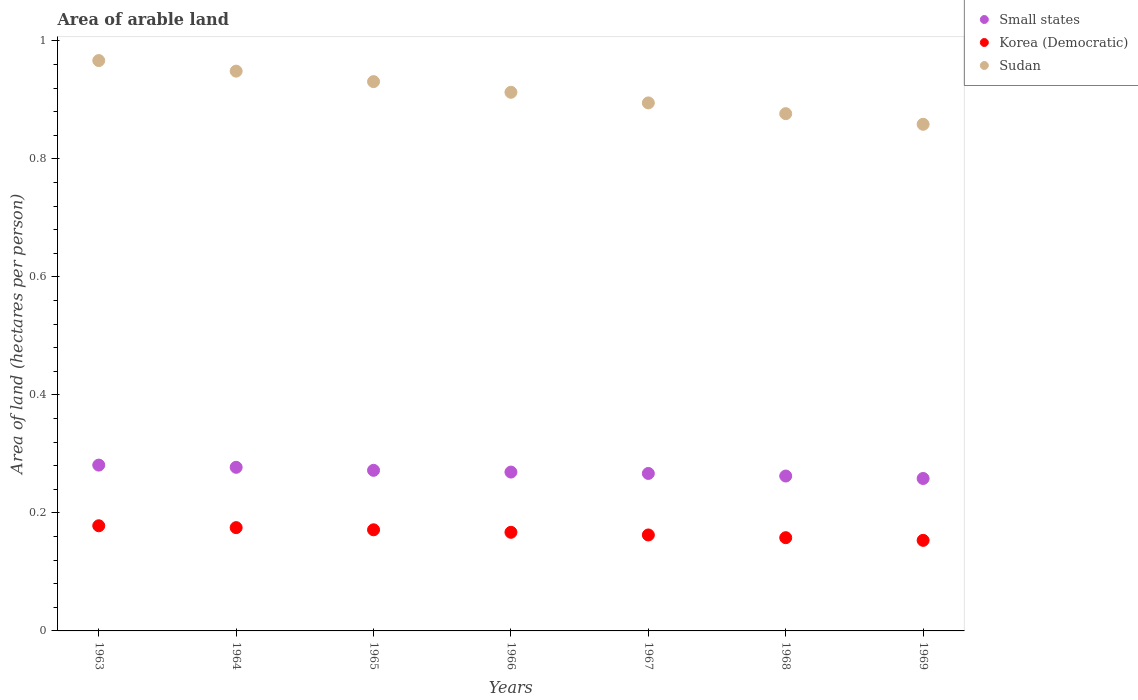How many different coloured dotlines are there?
Provide a short and direct response. 3. Is the number of dotlines equal to the number of legend labels?
Your answer should be compact. Yes. What is the total arable land in Sudan in 1969?
Ensure brevity in your answer.  0.86. Across all years, what is the maximum total arable land in Korea (Democratic)?
Make the answer very short. 0.18. Across all years, what is the minimum total arable land in Sudan?
Make the answer very short. 0.86. In which year was the total arable land in Small states maximum?
Make the answer very short. 1963. In which year was the total arable land in Small states minimum?
Give a very brief answer. 1969. What is the total total arable land in Sudan in the graph?
Give a very brief answer. 6.39. What is the difference between the total arable land in Small states in 1963 and that in 1967?
Ensure brevity in your answer.  0.01. What is the difference between the total arable land in Korea (Democratic) in 1963 and the total arable land in Small states in 1964?
Ensure brevity in your answer.  -0.1. What is the average total arable land in Small states per year?
Offer a terse response. 0.27. In the year 1967, what is the difference between the total arable land in Korea (Democratic) and total arable land in Sudan?
Offer a terse response. -0.73. In how many years, is the total arable land in Small states greater than 0.36 hectares per person?
Your answer should be very brief. 0. What is the ratio of the total arable land in Sudan in 1968 to that in 1969?
Ensure brevity in your answer.  1.02. Is the total arable land in Sudan in 1966 less than that in 1969?
Make the answer very short. No. What is the difference between the highest and the second highest total arable land in Korea (Democratic)?
Your response must be concise. 0. What is the difference between the highest and the lowest total arable land in Sudan?
Your answer should be very brief. 0.11. Is the sum of the total arable land in Small states in 1964 and 1968 greater than the maximum total arable land in Sudan across all years?
Keep it short and to the point. No. Is it the case that in every year, the sum of the total arable land in Korea (Democratic) and total arable land in Sudan  is greater than the total arable land in Small states?
Provide a short and direct response. Yes. Does the total arable land in Small states monotonically increase over the years?
Provide a short and direct response. No. What is the difference between two consecutive major ticks on the Y-axis?
Make the answer very short. 0.2. Does the graph contain any zero values?
Your answer should be very brief. No. Does the graph contain grids?
Keep it short and to the point. No. Where does the legend appear in the graph?
Give a very brief answer. Top right. What is the title of the graph?
Offer a terse response. Area of arable land. What is the label or title of the X-axis?
Your answer should be very brief. Years. What is the label or title of the Y-axis?
Your answer should be compact. Area of land (hectares per person). What is the Area of land (hectares per person) in Small states in 1963?
Give a very brief answer. 0.28. What is the Area of land (hectares per person) in Korea (Democratic) in 1963?
Your answer should be compact. 0.18. What is the Area of land (hectares per person) in Sudan in 1963?
Offer a very short reply. 0.97. What is the Area of land (hectares per person) of Small states in 1964?
Your answer should be compact. 0.28. What is the Area of land (hectares per person) in Korea (Democratic) in 1964?
Make the answer very short. 0.18. What is the Area of land (hectares per person) of Sudan in 1964?
Your response must be concise. 0.95. What is the Area of land (hectares per person) of Small states in 1965?
Offer a very short reply. 0.27. What is the Area of land (hectares per person) of Korea (Democratic) in 1965?
Give a very brief answer. 0.17. What is the Area of land (hectares per person) of Sudan in 1965?
Ensure brevity in your answer.  0.93. What is the Area of land (hectares per person) of Small states in 1966?
Your answer should be very brief. 0.27. What is the Area of land (hectares per person) of Korea (Democratic) in 1966?
Provide a short and direct response. 0.17. What is the Area of land (hectares per person) in Sudan in 1966?
Your answer should be compact. 0.91. What is the Area of land (hectares per person) of Small states in 1967?
Keep it short and to the point. 0.27. What is the Area of land (hectares per person) in Korea (Democratic) in 1967?
Provide a short and direct response. 0.16. What is the Area of land (hectares per person) in Sudan in 1967?
Provide a short and direct response. 0.89. What is the Area of land (hectares per person) of Small states in 1968?
Provide a short and direct response. 0.26. What is the Area of land (hectares per person) in Korea (Democratic) in 1968?
Offer a terse response. 0.16. What is the Area of land (hectares per person) in Sudan in 1968?
Your answer should be very brief. 0.88. What is the Area of land (hectares per person) in Small states in 1969?
Provide a succinct answer. 0.26. What is the Area of land (hectares per person) of Korea (Democratic) in 1969?
Your answer should be compact. 0.15. What is the Area of land (hectares per person) in Sudan in 1969?
Your answer should be very brief. 0.86. Across all years, what is the maximum Area of land (hectares per person) in Small states?
Give a very brief answer. 0.28. Across all years, what is the maximum Area of land (hectares per person) of Korea (Democratic)?
Give a very brief answer. 0.18. Across all years, what is the maximum Area of land (hectares per person) of Sudan?
Offer a terse response. 0.97. Across all years, what is the minimum Area of land (hectares per person) of Small states?
Offer a very short reply. 0.26. Across all years, what is the minimum Area of land (hectares per person) in Korea (Democratic)?
Provide a short and direct response. 0.15. Across all years, what is the minimum Area of land (hectares per person) of Sudan?
Give a very brief answer. 0.86. What is the total Area of land (hectares per person) of Small states in the graph?
Give a very brief answer. 1.89. What is the total Area of land (hectares per person) in Korea (Democratic) in the graph?
Ensure brevity in your answer.  1.17. What is the total Area of land (hectares per person) of Sudan in the graph?
Your response must be concise. 6.39. What is the difference between the Area of land (hectares per person) of Small states in 1963 and that in 1964?
Offer a terse response. 0. What is the difference between the Area of land (hectares per person) of Korea (Democratic) in 1963 and that in 1964?
Keep it short and to the point. 0. What is the difference between the Area of land (hectares per person) of Sudan in 1963 and that in 1964?
Keep it short and to the point. 0.02. What is the difference between the Area of land (hectares per person) of Small states in 1963 and that in 1965?
Your answer should be very brief. 0.01. What is the difference between the Area of land (hectares per person) of Korea (Democratic) in 1963 and that in 1965?
Make the answer very short. 0.01. What is the difference between the Area of land (hectares per person) in Sudan in 1963 and that in 1965?
Your answer should be very brief. 0.04. What is the difference between the Area of land (hectares per person) of Small states in 1963 and that in 1966?
Keep it short and to the point. 0.01. What is the difference between the Area of land (hectares per person) of Korea (Democratic) in 1963 and that in 1966?
Offer a terse response. 0.01. What is the difference between the Area of land (hectares per person) of Sudan in 1963 and that in 1966?
Provide a succinct answer. 0.05. What is the difference between the Area of land (hectares per person) in Small states in 1963 and that in 1967?
Your response must be concise. 0.01. What is the difference between the Area of land (hectares per person) of Korea (Democratic) in 1963 and that in 1967?
Your response must be concise. 0.02. What is the difference between the Area of land (hectares per person) in Sudan in 1963 and that in 1967?
Provide a succinct answer. 0.07. What is the difference between the Area of land (hectares per person) in Small states in 1963 and that in 1968?
Make the answer very short. 0.02. What is the difference between the Area of land (hectares per person) in Korea (Democratic) in 1963 and that in 1968?
Offer a very short reply. 0.02. What is the difference between the Area of land (hectares per person) of Sudan in 1963 and that in 1968?
Your answer should be compact. 0.09. What is the difference between the Area of land (hectares per person) in Small states in 1963 and that in 1969?
Provide a short and direct response. 0.02. What is the difference between the Area of land (hectares per person) of Korea (Democratic) in 1963 and that in 1969?
Your answer should be very brief. 0.02. What is the difference between the Area of land (hectares per person) in Sudan in 1963 and that in 1969?
Provide a succinct answer. 0.11. What is the difference between the Area of land (hectares per person) of Small states in 1964 and that in 1965?
Your answer should be very brief. 0.01. What is the difference between the Area of land (hectares per person) in Korea (Democratic) in 1964 and that in 1965?
Ensure brevity in your answer.  0. What is the difference between the Area of land (hectares per person) in Sudan in 1964 and that in 1965?
Provide a succinct answer. 0.02. What is the difference between the Area of land (hectares per person) of Small states in 1964 and that in 1966?
Your answer should be very brief. 0.01. What is the difference between the Area of land (hectares per person) in Korea (Democratic) in 1964 and that in 1966?
Your answer should be compact. 0.01. What is the difference between the Area of land (hectares per person) of Sudan in 1964 and that in 1966?
Your answer should be very brief. 0.04. What is the difference between the Area of land (hectares per person) of Small states in 1964 and that in 1967?
Offer a very short reply. 0.01. What is the difference between the Area of land (hectares per person) in Korea (Democratic) in 1964 and that in 1967?
Offer a terse response. 0.01. What is the difference between the Area of land (hectares per person) of Sudan in 1964 and that in 1967?
Give a very brief answer. 0.05. What is the difference between the Area of land (hectares per person) in Small states in 1964 and that in 1968?
Provide a succinct answer. 0.01. What is the difference between the Area of land (hectares per person) in Korea (Democratic) in 1964 and that in 1968?
Provide a succinct answer. 0.02. What is the difference between the Area of land (hectares per person) in Sudan in 1964 and that in 1968?
Keep it short and to the point. 0.07. What is the difference between the Area of land (hectares per person) in Small states in 1964 and that in 1969?
Provide a succinct answer. 0.02. What is the difference between the Area of land (hectares per person) in Korea (Democratic) in 1964 and that in 1969?
Ensure brevity in your answer.  0.02. What is the difference between the Area of land (hectares per person) in Sudan in 1964 and that in 1969?
Your answer should be very brief. 0.09. What is the difference between the Area of land (hectares per person) in Small states in 1965 and that in 1966?
Provide a short and direct response. 0. What is the difference between the Area of land (hectares per person) in Korea (Democratic) in 1965 and that in 1966?
Provide a short and direct response. 0. What is the difference between the Area of land (hectares per person) of Sudan in 1965 and that in 1966?
Ensure brevity in your answer.  0.02. What is the difference between the Area of land (hectares per person) of Small states in 1965 and that in 1967?
Your response must be concise. 0.01. What is the difference between the Area of land (hectares per person) in Korea (Democratic) in 1965 and that in 1967?
Make the answer very short. 0.01. What is the difference between the Area of land (hectares per person) in Sudan in 1965 and that in 1967?
Your answer should be very brief. 0.04. What is the difference between the Area of land (hectares per person) in Small states in 1965 and that in 1968?
Keep it short and to the point. 0.01. What is the difference between the Area of land (hectares per person) of Korea (Democratic) in 1965 and that in 1968?
Offer a very short reply. 0.01. What is the difference between the Area of land (hectares per person) of Sudan in 1965 and that in 1968?
Your response must be concise. 0.05. What is the difference between the Area of land (hectares per person) of Small states in 1965 and that in 1969?
Make the answer very short. 0.01. What is the difference between the Area of land (hectares per person) of Korea (Democratic) in 1965 and that in 1969?
Keep it short and to the point. 0.02. What is the difference between the Area of land (hectares per person) in Sudan in 1965 and that in 1969?
Your response must be concise. 0.07. What is the difference between the Area of land (hectares per person) of Small states in 1966 and that in 1967?
Provide a short and direct response. 0. What is the difference between the Area of land (hectares per person) of Korea (Democratic) in 1966 and that in 1967?
Make the answer very short. 0. What is the difference between the Area of land (hectares per person) of Sudan in 1966 and that in 1967?
Provide a short and direct response. 0.02. What is the difference between the Area of land (hectares per person) in Small states in 1966 and that in 1968?
Give a very brief answer. 0.01. What is the difference between the Area of land (hectares per person) of Korea (Democratic) in 1966 and that in 1968?
Offer a very short reply. 0.01. What is the difference between the Area of land (hectares per person) of Sudan in 1966 and that in 1968?
Offer a terse response. 0.04. What is the difference between the Area of land (hectares per person) of Small states in 1966 and that in 1969?
Your response must be concise. 0.01. What is the difference between the Area of land (hectares per person) of Korea (Democratic) in 1966 and that in 1969?
Your answer should be compact. 0.01. What is the difference between the Area of land (hectares per person) of Sudan in 1966 and that in 1969?
Provide a succinct answer. 0.05. What is the difference between the Area of land (hectares per person) of Small states in 1967 and that in 1968?
Provide a short and direct response. 0. What is the difference between the Area of land (hectares per person) of Korea (Democratic) in 1967 and that in 1968?
Make the answer very short. 0. What is the difference between the Area of land (hectares per person) in Sudan in 1967 and that in 1968?
Provide a short and direct response. 0.02. What is the difference between the Area of land (hectares per person) of Small states in 1967 and that in 1969?
Ensure brevity in your answer.  0.01. What is the difference between the Area of land (hectares per person) in Korea (Democratic) in 1967 and that in 1969?
Offer a terse response. 0.01. What is the difference between the Area of land (hectares per person) in Sudan in 1967 and that in 1969?
Offer a very short reply. 0.04. What is the difference between the Area of land (hectares per person) of Small states in 1968 and that in 1969?
Your answer should be very brief. 0. What is the difference between the Area of land (hectares per person) of Korea (Democratic) in 1968 and that in 1969?
Make the answer very short. 0. What is the difference between the Area of land (hectares per person) in Sudan in 1968 and that in 1969?
Keep it short and to the point. 0.02. What is the difference between the Area of land (hectares per person) in Small states in 1963 and the Area of land (hectares per person) in Korea (Democratic) in 1964?
Give a very brief answer. 0.11. What is the difference between the Area of land (hectares per person) of Small states in 1963 and the Area of land (hectares per person) of Sudan in 1964?
Offer a very short reply. -0.67. What is the difference between the Area of land (hectares per person) in Korea (Democratic) in 1963 and the Area of land (hectares per person) in Sudan in 1964?
Provide a succinct answer. -0.77. What is the difference between the Area of land (hectares per person) of Small states in 1963 and the Area of land (hectares per person) of Korea (Democratic) in 1965?
Provide a short and direct response. 0.11. What is the difference between the Area of land (hectares per person) in Small states in 1963 and the Area of land (hectares per person) in Sudan in 1965?
Offer a terse response. -0.65. What is the difference between the Area of land (hectares per person) of Korea (Democratic) in 1963 and the Area of land (hectares per person) of Sudan in 1965?
Your answer should be very brief. -0.75. What is the difference between the Area of land (hectares per person) in Small states in 1963 and the Area of land (hectares per person) in Korea (Democratic) in 1966?
Give a very brief answer. 0.11. What is the difference between the Area of land (hectares per person) in Small states in 1963 and the Area of land (hectares per person) in Sudan in 1966?
Provide a short and direct response. -0.63. What is the difference between the Area of land (hectares per person) of Korea (Democratic) in 1963 and the Area of land (hectares per person) of Sudan in 1966?
Make the answer very short. -0.73. What is the difference between the Area of land (hectares per person) in Small states in 1963 and the Area of land (hectares per person) in Korea (Democratic) in 1967?
Offer a terse response. 0.12. What is the difference between the Area of land (hectares per person) of Small states in 1963 and the Area of land (hectares per person) of Sudan in 1967?
Your response must be concise. -0.61. What is the difference between the Area of land (hectares per person) of Korea (Democratic) in 1963 and the Area of land (hectares per person) of Sudan in 1967?
Offer a terse response. -0.72. What is the difference between the Area of land (hectares per person) in Small states in 1963 and the Area of land (hectares per person) in Korea (Democratic) in 1968?
Keep it short and to the point. 0.12. What is the difference between the Area of land (hectares per person) of Small states in 1963 and the Area of land (hectares per person) of Sudan in 1968?
Your answer should be very brief. -0.6. What is the difference between the Area of land (hectares per person) in Korea (Democratic) in 1963 and the Area of land (hectares per person) in Sudan in 1968?
Keep it short and to the point. -0.7. What is the difference between the Area of land (hectares per person) in Small states in 1963 and the Area of land (hectares per person) in Korea (Democratic) in 1969?
Offer a very short reply. 0.13. What is the difference between the Area of land (hectares per person) of Small states in 1963 and the Area of land (hectares per person) of Sudan in 1969?
Keep it short and to the point. -0.58. What is the difference between the Area of land (hectares per person) in Korea (Democratic) in 1963 and the Area of land (hectares per person) in Sudan in 1969?
Provide a succinct answer. -0.68. What is the difference between the Area of land (hectares per person) of Small states in 1964 and the Area of land (hectares per person) of Korea (Democratic) in 1965?
Your answer should be very brief. 0.11. What is the difference between the Area of land (hectares per person) of Small states in 1964 and the Area of land (hectares per person) of Sudan in 1965?
Offer a very short reply. -0.65. What is the difference between the Area of land (hectares per person) in Korea (Democratic) in 1964 and the Area of land (hectares per person) in Sudan in 1965?
Keep it short and to the point. -0.76. What is the difference between the Area of land (hectares per person) in Small states in 1964 and the Area of land (hectares per person) in Korea (Democratic) in 1966?
Keep it short and to the point. 0.11. What is the difference between the Area of land (hectares per person) of Small states in 1964 and the Area of land (hectares per person) of Sudan in 1966?
Keep it short and to the point. -0.64. What is the difference between the Area of land (hectares per person) of Korea (Democratic) in 1964 and the Area of land (hectares per person) of Sudan in 1966?
Offer a terse response. -0.74. What is the difference between the Area of land (hectares per person) of Small states in 1964 and the Area of land (hectares per person) of Korea (Democratic) in 1967?
Make the answer very short. 0.11. What is the difference between the Area of land (hectares per person) in Small states in 1964 and the Area of land (hectares per person) in Sudan in 1967?
Your answer should be compact. -0.62. What is the difference between the Area of land (hectares per person) in Korea (Democratic) in 1964 and the Area of land (hectares per person) in Sudan in 1967?
Offer a terse response. -0.72. What is the difference between the Area of land (hectares per person) of Small states in 1964 and the Area of land (hectares per person) of Korea (Democratic) in 1968?
Offer a very short reply. 0.12. What is the difference between the Area of land (hectares per person) in Small states in 1964 and the Area of land (hectares per person) in Sudan in 1968?
Keep it short and to the point. -0.6. What is the difference between the Area of land (hectares per person) of Korea (Democratic) in 1964 and the Area of land (hectares per person) of Sudan in 1968?
Make the answer very short. -0.7. What is the difference between the Area of land (hectares per person) of Small states in 1964 and the Area of land (hectares per person) of Korea (Democratic) in 1969?
Offer a very short reply. 0.12. What is the difference between the Area of land (hectares per person) in Small states in 1964 and the Area of land (hectares per person) in Sudan in 1969?
Ensure brevity in your answer.  -0.58. What is the difference between the Area of land (hectares per person) in Korea (Democratic) in 1964 and the Area of land (hectares per person) in Sudan in 1969?
Your response must be concise. -0.68. What is the difference between the Area of land (hectares per person) of Small states in 1965 and the Area of land (hectares per person) of Korea (Democratic) in 1966?
Provide a short and direct response. 0.1. What is the difference between the Area of land (hectares per person) in Small states in 1965 and the Area of land (hectares per person) in Sudan in 1966?
Provide a short and direct response. -0.64. What is the difference between the Area of land (hectares per person) of Korea (Democratic) in 1965 and the Area of land (hectares per person) of Sudan in 1966?
Offer a very short reply. -0.74. What is the difference between the Area of land (hectares per person) of Small states in 1965 and the Area of land (hectares per person) of Korea (Democratic) in 1967?
Provide a succinct answer. 0.11. What is the difference between the Area of land (hectares per person) of Small states in 1965 and the Area of land (hectares per person) of Sudan in 1967?
Your answer should be compact. -0.62. What is the difference between the Area of land (hectares per person) of Korea (Democratic) in 1965 and the Area of land (hectares per person) of Sudan in 1967?
Your answer should be very brief. -0.72. What is the difference between the Area of land (hectares per person) of Small states in 1965 and the Area of land (hectares per person) of Korea (Democratic) in 1968?
Provide a succinct answer. 0.11. What is the difference between the Area of land (hectares per person) of Small states in 1965 and the Area of land (hectares per person) of Sudan in 1968?
Make the answer very short. -0.6. What is the difference between the Area of land (hectares per person) in Korea (Democratic) in 1965 and the Area of land (hectares per person) in Sudan in 1968?
Provide a short and direct response. -0.71. What is the difference between the Area of land (hectares per person) of Small states in 1965 and the Area of land (hectares per person) of Korea (Democratic) in 1969?
Your response must be concise. 0.12. What is the difference between the Area of land (hectares per person) of Small states in 1965 and the Area of land (hectares per person) of Sudan in 1969?
Provide a short and direct response. -0.59. What is the difference between the Area of land (hectares per person) in Korea (Democratic) in 1965 and the Area of land (hectares per person) in Sudan in 1969?
Offer a terse response. -0.69. What is the difference between the Area of land (hectares per person) in Small states in 1966 and the Area of land (hectares per person) in Korea (Democratic) in 1967?
Your answer should be very brief. 0.11. What is the difference between the Area of land (hectares per person) of Small states in 1966 and the Area of land (hectares per person) of Sudan in 1967?
Your answer should be very brief. -0.63. What is the difference between the Area of land (hectares per person) in Korea (Democratic) in 1966 and the Area of land (hectares per person) in Sudan in 1967?
Provide a succinct answer. -0.73. What is the difference between the Area of land (hectares per person) in Small states in 1966 and the Area of land (hectares per person) in Korea (Democratic) in 1968?
Your response must be concise. 0.11. What is the difference between the Area of land (hectares per person) in Small states in 1966 and the Area of land (hectares per person) in Sudan in 1968?
Offer a terse response. -0.61. What is the difference between the Area of land (hectares per person) of Korea (Democratic) in 1966 and the Area of land (hectares per person) of Sudan in 1968?
Your answer should be compact. -0.71. What is the difference between the Area of land (hectares per person) of Small states in 1966 and the Area of land (hectares per person) of Korea (Democratic) in 1969?
Make the answer very short. 0.12. What is the difference between the Area of land (hectares per person) in Small states in 1966 and the Area of land (hectares per person) in Sudan in 1969?
Make the answer very short. -0.59. What is the difference between the Area of land (hectares per person) in Korea (Democratic) in 1966 and the Area of land (hectares per person) in Sudan in 1969?
Offer a terse response. -0.69. What is the difference between the Area of land (hectares per person) in Small states in 1967 and the Area of land (hectares per person) in Korea (Democratic) in 1968?
Keep it short and to the point. 0.11. What is the difference between the Area of land (hectares per person) of Small states in 1967 and the Area of land (hectares per person) of Sudan in 1968?
Make the answer very short. -0.61. What is the difference between the Area of land (hectares per person) in Korea (Democratic) in 1967 and the Area of land (hectares per person) in Sudan in 1968?
Provide a short and direct response. -0.71. What is the difference between the Area of land (hectares per person) in Small states in 1967 and the Area of land (hectares per person) in Korea (Democratic) in 1969?
Offer a terse response. 0.11. What is the difference between the Area of land (hectares per person) in Small states in 1967 and the Area of land (hectares per person) in Sudan in 1969?
Your answer should be very brief. -0.59. What is the difference between the Area of land (hectares per person) in Korea (Democratic) in 1967 and the Area of land (hectares per person) in Sudan in 1969?
Your response must be concise. -0.7. What is the difference between the Area of land (hectares per person) in Small states in 1968 and the Area of land (hectares per person) in Korea (Democratic) in 1969?
Your answer should be very brief. 0.11. What is the difference between the Area of land (hectares per person) of Small states in 1968 and the Area of land (hectares per person) of Sudan in 1969?
Ensure brevity in your answer.  -0.6. What is the difference between the Area of land (hectares per person) in Korea (Democratic) in 1968 and the Area of land (hectares per person) in Sudan in 1969?
Give a very brief answer. -0.7. What is the average Area of land (hectares per person) in Small states per year?
Give a very brief answer. 0.27. What is the average Area of land (hectares per person) of Korea (Democratic) per year?
Your response must be concise. 0.17. What is the average Area of land (hectares per person) of Sudan per year?
Give a very brief answer. 0.91. In the year 1963, what is the difference between the Area of land (hectares per person) in Small states and Area of land (hectares per person) in Korea (Democratic)?
Your response must be concise. 0.1. In the year 1963, what is the difference between the Area of land (hectares per person) of Small states and Area of land (hectares per person) of Sudan?
Provide a short and direct response. -0.69. In the year 1963, what is the difference between the Area of land (hectares per person) in Korea (Democratic) and Area of land (hectares per person) in Sudan?
Ensure brevity in your answer.  -0.79. In the year 1964, what is the difference between the Area of land (hectares per person) in Small states and Area of land (hectares per person) in Korea (Democratic)?
Your answer should be very brief. 0.1. In the year 1964, what is the difference between the Area of land (hectares per person) in Small states and Area of land (hectares per person) in Sudan?
Provide a short and direct response. -0.67. In the year 1964, what is the difference between the Area of land (hectares per person) in Korea (Democratic) and Area of land (hectares per person) in Sudan?
Your response must be concise. -0.77. In the year 1965, what is the difference between the Area of land (hectares per person) of Small states and Area of land (hectares per person) of Korea (Democratic)?
Offer a terse response. 0.1. In the year 1965, what is the difference between the Area of land (hectares per person) of Small states and Area of land (hectares per person) of Sudan?
Give a very brief answer. -0.66. In the year 1965, what is the difference between the Area of land (hectares per person) in Korea (Democratic) and Area of land (hectares per person) in Sudan?
Keep it short and to the point. -0.76. In the year 1966, what is the difference between the Area of land (hectares per person) in Small states and Area of land (hectares per person) in Korea (Democratic)?
Your answer should be very brief. 0.1. In the year 1966, what is the difference between the Area of land (hectares per person) in Small states and Area of land (hectares per person) in Sudan?
Provide a succinct answer. -0.64. In the year 1966, what is the difference between the Area of land (hectares per person) of Korea (Democratic) and Area of land (hectares per person) of Sudan?
Your answer should be very brief. -0.75. In the year 1967, what is the difference between the Area of land (hectares per person) of Small states and Area of land (hectares per person) of Korea (Democratic)?
Your response must be concise. 0.1. In the year 1967, what is the difference between the Area of land (hectares per person) of Small states and Area of land (hectares per person) of Sudan?
Provide a succinct answer. -0.63. In the year 1967, what is the difference between the Area of land (hectares per person) of Korea (Democratic) and Area of land (hectares per person) of Sudan?
Provide a succinct answer. -0.73. In the year 1968, what is the difference between the Area of land (hectares per person) of Small states and Area of land (hectares per person) of Korea (Democratic)?
Ensure brevity in your answer.  0.1. In the year 1968, what is the difference between the Area of land (hectares per person) in Small states and Area of land (hectares per person) in Sudan?
Provide a short and direct response. -0.61. In the year 1968, what is the difference between the Area of land (hectares per person) of Korea (Democratic) and Area of land (hectares per person) of Sudan?
Offer a terse response. -0.72. In the year 1969, what is the difference between the Area of land (hectares per person) of Small states and Area of land (hectares per person) of Korea (Democratic)?
Keep it short and to the point. 0.1. In the year 1969, what is the difference between the Area of land (hectares per person) in Small states and Area of land (hectares per person) in Sudan?
Offer a very short reply. -0.6. In the year 1969, what is the difference between the Area of land (hectares per person) of Korea (Democratic) and Area of land (hectares per person) of Sudan?
Ensure brevity in your answer.  -0.7. What is the ratio of the Area of land (hectares per person) in Small states in 1963 to that in 1964?
Give a very brief answer. 1.01. What is the ratio of the Area of land (hectares per person) in Korea (Democratic) in 1963 to that in 1964?
Provide a succinct answer. 1.02. What is the ratio of the Area of land (hectares per person) in Sudan in 1963 to that in 1964?
Offer a very short reply. 1.02. What is the ratio of the Area of land (hectares per person) of Small states in 1963 to that in 1965?
Ensure brevity in your answer.  1.03. What is the ratio of the Area of land (hectares per person) in Sudan in 1963 to that in 1965?
Offer a very short reply. 1.04. What is the ratio of the Area of land (hectares per person) in Small states in 1963 to that in 1966?
Provide a short and direct response. 1.04. What is the ratio of the Area of land (hectares per person) of Korea (Democratic) in 1963 to that in 1966?
Keep it short and to the point. 1.07. What is the ratio of the Area of land (hectares per person) in Sudan in 1963 to that in 1966?
Offer a very short reply. 1.06. What is the ratio of the Area of land (hectares per person) of Small states in 1963 to that in 1967?
Make the answer very short. 1.05. What is the ratio of the Area of land (hectares per person) of Korea (Democratic) in 1963 to that in 1967?
Provide a short and direct response. 1.1. What is the ratio of the Area of land (hectares per person) in Sudan in 1963 to that in 1967?
Provide a succinct answer. 1.08. What is the ratio of the Area of land (hectares per person) of Small states in 1963 to that in 1968?
Offer a very short reply. 1.07. What is the ratio of the Area of land (hectares per person) in Korea (Democratic) in 1963 to that in 1968?
Ensure brevity in your answer.  1.13. What is the ratio of the Area of land (hectares per person) of Sudan in 1963 to that in 1968?
Your answer should be very brief. 1.1. What is the ratio of the Area of land (hectares per person) of Small states in 1963 to that in 1969?
Keep it short and to the point. 1.09. What is the ratio of the Area of land (hectares per person) of Korea (Democratic) in 1963 to that in 1969?
Provide a short and direct response. 1.16. What is the ratio of the Area of land (hectares per person) in Sudan in 1963 to that in 1969?
Your answer should be very brief. 1.13. What is the ratio of the Area of land (hectares per person) of Small states in 1964 to that in 1965?
Keep it short and to the point. 1.02. What is the ratio of the Area of land (hectares per person) of Korea (Democratic) in 1964 to that in 1965?
Provide a succinct answer. 1.02. What is the ratio of the Area of land (hectares per person) in Sudan in 1964 to that in 1965?
Give a very brief answer. 1.02. What is the ratio of the Area of land (hectares per person) in Korea (Democratic) in 1964 to that in 1966?
Give a very brief answer. 1.05. What is the ratio of the Area of land (hectares per person) in Sudan in 1964 to that in 1966?
Give a very brief answer. 1.04. What is the ratio of the Area of land (hectares per person) of Small states in 1964 to that in 1967?
Your response must be concise. 1.04. What is the ratio of the Area of land (hectares per person) of Korea (Democratic) in 1964 to that in 1967?
Keep it short and to the point. 1.08. What is the ratio of the Area of land (hectares per person) in Sudan in 1964 to that in 1967?
Offer a very short reply. 1.06. What is the ratio of the Area of land (hectares per person) in Small states in 1964 to that in 1968?
Ensure brevity in your answer.  1.06. What is the ratio of the Area of land (hectares per person) in Korea (Democratic) in 1964 to that in 1968?
Offer a very short reply. 1.11. What is the ratio of the Area of land (hectares per person) of Sudan in 1964 to that in 1968?
Offer a very short reply. 1.08. What is the ratio of the Area of land (hectares per person) of Small states in 1964 to that in 1969?
Provide a short and direct response. 1.07. What is the ratio of the Area of land (hectares per person) of Korea (Democratic) in 1964 to that in 1969?
Your answer should be compact. 1.14. What is the ratio of the Area of land (hectares per person) of Sudan in 1964 to that in 1969?
Offer a terse response. 1.1. What is the ratio of the Area of land (hectares per person) of Small states in 1965 to that in 1966?
Offer a terse response. 1.01. What is the ratio of the Area of land (hectares per person) of Korea (Democratic) in 1965 to that in 1966?
Your answer should be compact. 1.03. What is the ratio of the Area of land (hectares per person) of Sudan in 1965 to that in 1966?
Make the answer very short. 1.02. What is the ratio of the Area of land (hectares per person) of Small states in 1965 to that in 1967?
Give a very brief answer. 1.02. What is the ratio of the Area of land (hectares per person) of Korea (Democratic) in 1965 to that in 1967?
Ensure brevity in your answer.  1.05. What is the ratio of the Area of land (hectares per person) of Sudan in 1965 to that in 1967?
Your answer should be very brief. 1.04. What is the ratio of the Area of land (hectares per person) of Small states in 1965 to that in 1968?
Offer a very short reply. 1.04. What is the ratio of the Area of land (hectares per person) in Korea (Democratic) in 1965 to that in 1968?
Your answer should be very brief. 1.08. What is the ratio of the Area of land (hectares per person) of Sudan in 1965 to that in 1968?
Give a very brief answer. 1.06. What is the ratio of the Area of land (hectares per person) of Small states in 1965 to that in 1969?
Your answer should be very brief. 1.05. What is the ratio of the Area of land (hectares per person) in Korea (Democratic) in 1965 to that in 1969?
Make the answer very short. 1.12. What is the ratio of the Area of land (hectares per person) in Sudan in 1965 to that in 1969?
Give a very brief answer. 1.08. What is the ratio of the Area of land (hectares per person) in Small states in 1966 to that in 1967?
Provide a short and direct response. 1.01. What is the ratio of the Area of land (hectares per person) in Korea (Democratic) in 1966 to that in 1967?
Provide a succinct answer. 1.03. What is the ratio of the Area of land (hectares per person) of Sudan in 1966 to that in 1967?
Give a very brief answer. 1.02. What is the ratio of the Area of land (hectares per person) of Small states in 1966 to that in 1968?
Ensure brevity in your answer.  1.03. What is the ratio of the Area of land (hectares per person) in Korea (Democratic) in 1966 to that in 1968?
Your response must be concise. 1.06. What is the ratio of the Area of land (hectares per person) in Sudan in 1966 to that in 1968?
Offer a very short reply. 1.04. What is the ratio of the Area of land (hectares per person) in Small states in 1966 to that in 1969?
Offer a very short reply. 1.04. What is the ratio of the Area of land (hectares per person) in Korea (Democratic) in 1966 to that in 1969?
Make the answer very short. 1.09. What is the ratio of the Area of land (hectares per person) in Sudan in 1966 to that in 1969?
Make the answer very short. 1.06. What is the ratio of the Area of land (hectares per person) of Small states in 1967 to that in 1968?
Your answer should be very brief. 1.02. What is the ratio of the Area of land (hectares per person) of Korea (Democratic) in 1967 to that in 1968?
Offer a very short reply. 1.03. What is the ratio of the Area of land (hectares per person) in Sudan in 1967 to that in 1968?
Offer a very short reply. 1.02. What is the ratio of the Area of land (hectares per person) of Small states in 1967 to that in 1969?
Offer a terse response. 1.03. What is the ratio of the Area of land (hectares per person) in Korea (Democratic) in 1967 to that in 1969?
Provide a short and direct response. 1.06. What is the ratio of the Area of land (hectares per person) in Sudan in 1967 to that in 1969?
Your answer should be very brief. 1.04. What is the ratio of the Area of land (hectares per person) of Small states in 1968 to that in 1969?
Give a very brief answer. 1.02. What is the ratio of the Area of land (hectares per person) of Korea (Democratic) in 1968 to that in 1969?
Keep it short and to the point. 1.03. What is the ratio of the Area of land (hectares per person) of Sudan in 1968 to that in 1969?
Offer a terse response. 1.02. What is the difference between the highest and the second highest Area of land (hectares per person) of Small states?
Offer a very short reply. 0. What is the difference between the highest and the second highest Area of land (hectares per person) of Korea (Democratic)?
Offer a very short reply. 0. What is the difference between the highest and the second highest Area of land (hectares per person) of Sudan?
Provide a short and direct response. 0.02. What is the difference between the highest and the lowest Area of land (hectares per person) in Small states?
Offer a terse response. 0.02. What is the difference between the highest and the lowest Area of land (hectares per person) of Korea (Democratic)?
Your answer should be very brief. 0.02. What is the difference between the highest and the lowest Area of land (hectares per person) in Sudan?
Keep it short and to the point. 0.11. 